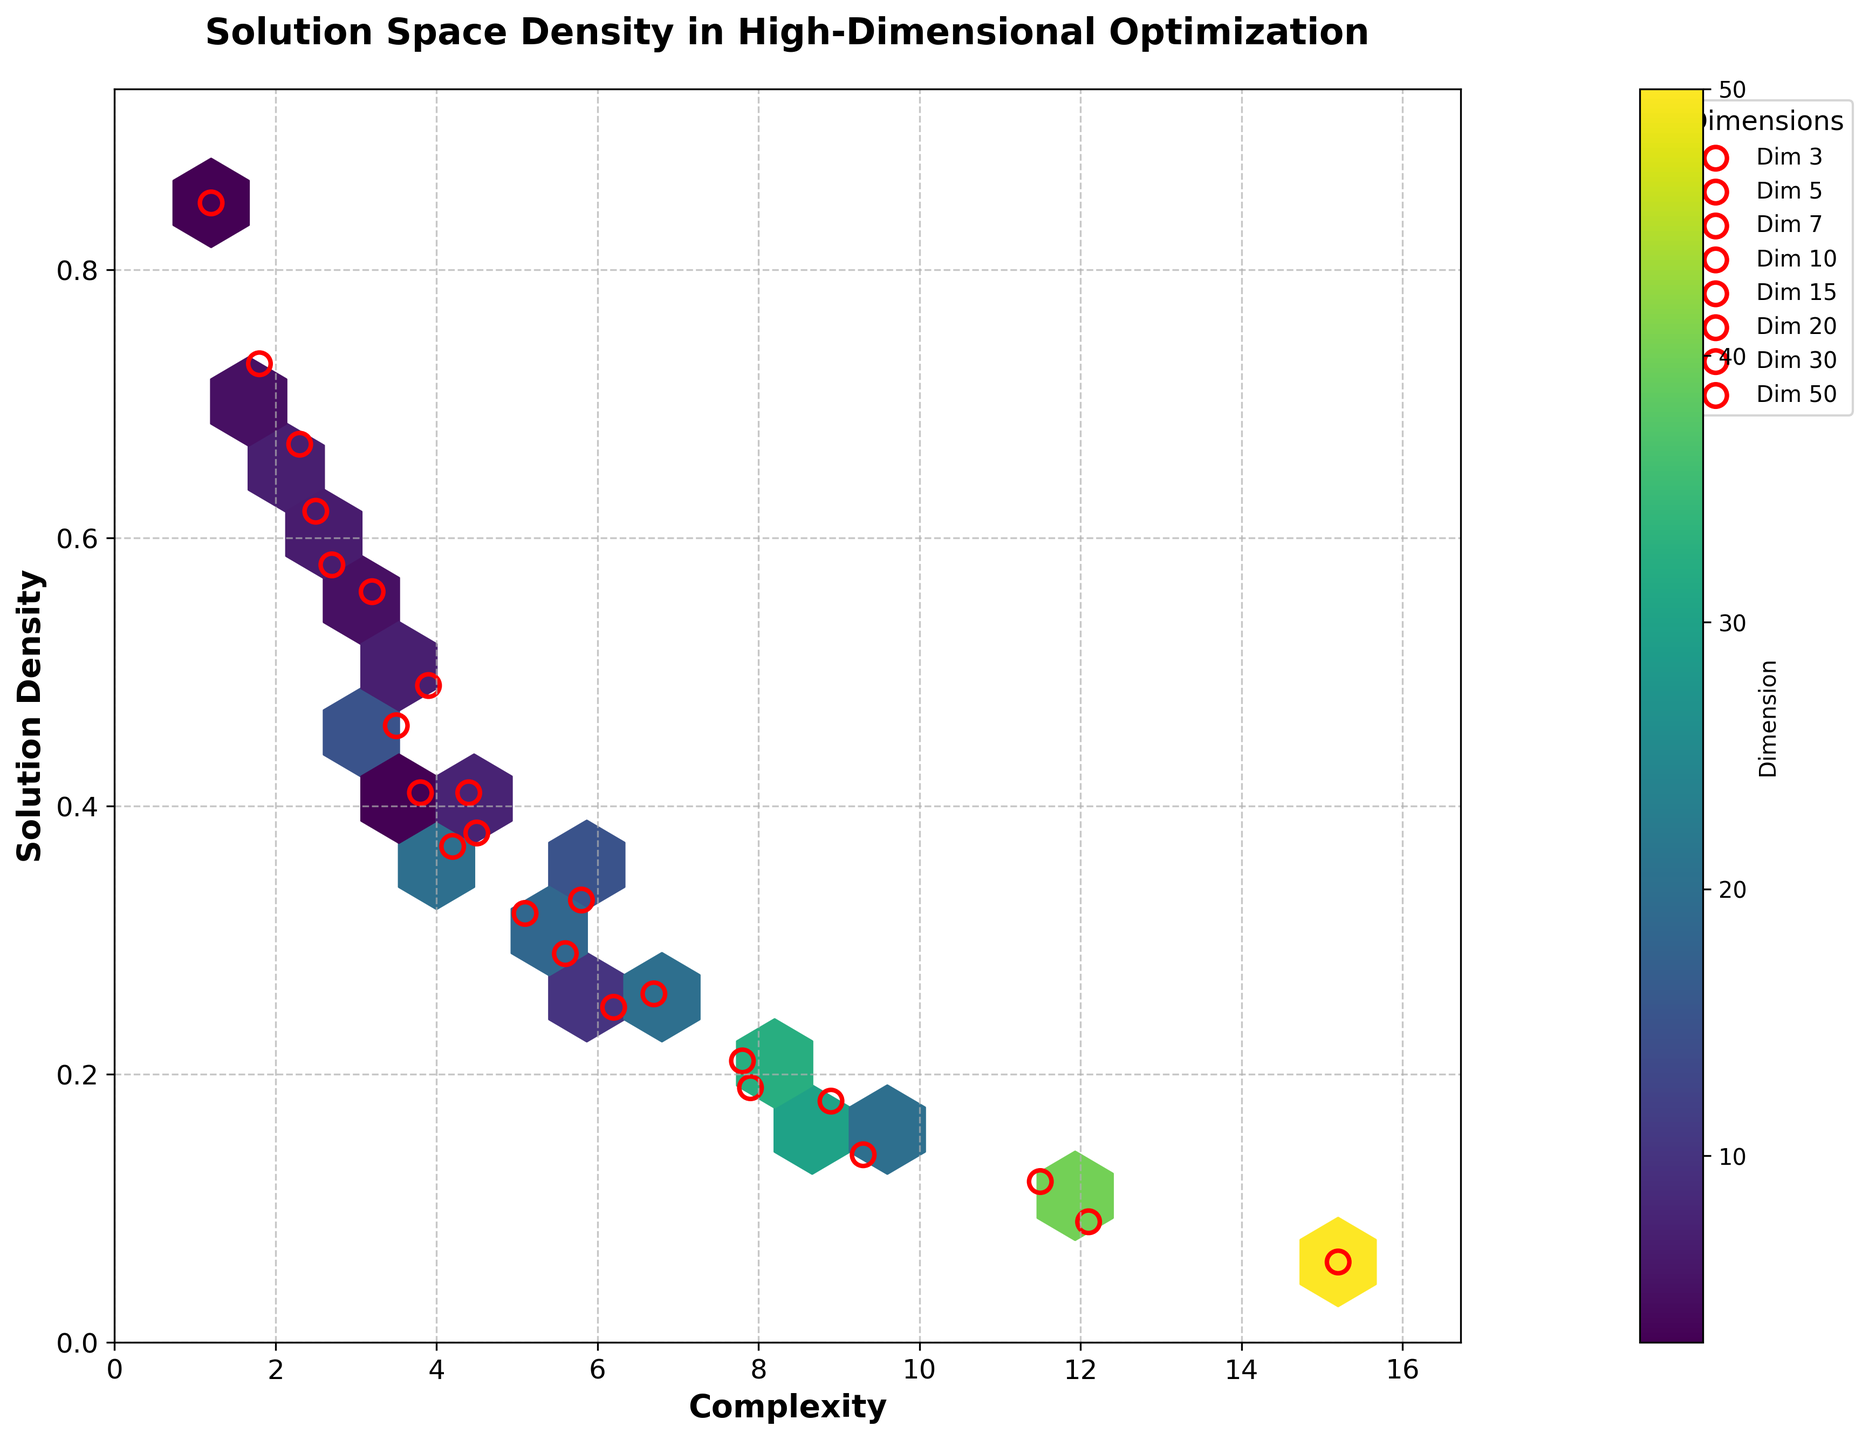What is the title of the figure? The title is displayed at the top of the figure and provides a concise description of its content. It reads "Solution Space Density in High-Dimensional Optimization".
Answer: Solution Space Density in High-Dimensional Optimization What are the labels of the x and y axes? The labels of the x and y axes describe the data dimensions represented along each axis. The x-axis is labeled "Complexity" and the y-axis is labeled "Solution Density".
Answer: Complexity, Solution Density Which dimension has the highest solution density? To determine the dimension with the highest solution density, locate the point with the maximum y-value and check its corresponding color bar value. The highest solution density (0.85) corresponds to the dimension 3.
Answer: 3 How many distinct dimension values are represented as scatter points on the figure? The scatter plot highlights different dimensions in red circles. By observing the legend, we can count the distinct dimension values, which are 8 in total (3, 5, 7, 10, 15, 20, 30, 50).
Answer: 8 Which dimension has the lowest solution density recorded and what is it? Locate the point with the minimum y-value among the scatter points. The lowest solution density (0.06) is recorded for the dimension 50.
Answer: 50, 0.06 For the dimension 20, which complexity value has the highest solution density and what is it? Specifically look at the red scatter points marked for dimension 20 in the legend. Identify the point with the highest y-value (solution density). The complexity value is 4.2, with a solution density of 0.37.
Answer: 4.2, 0.37 Compare the solution densities for dimensions 7 and 10. Which one has higher average solution density? First, identify the data points for dimensions 7 and 10. Calculate the average solution density for each dimension and compare them. For dimension 7: (0.67 + 0.49 + 0.32)/3 = 0.493, and for dimension 10: (0.58 + 0.41 + 0.25)/3 = 0.413. Dimension 7 has a higher average solution density.
Answer: 7 How does the solution density trend with increasing complexity for dimension 15? Observe the scatter points for dimension 15 as marked in the legend. Solution densities for complexities 3.5, 5.8, and 7.9 are 0.46, 0.33, and 0.19 respectively. There is a decreasing trend in solution density as complexity increases.
Answer: Decreasing Is there any dimension where solution density stays relatively consistent irrespective of complexity? Check for any dimension's scatter points where the solution densities do not vary significantly despite changes in complexity. None of the dimensions exhibit the same solution density values; all show variation with complexity changes.
Answer: No 